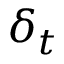<formula> <loc_0><loc_0><loc_500><loc_500>\delta _ { t }</formula> 